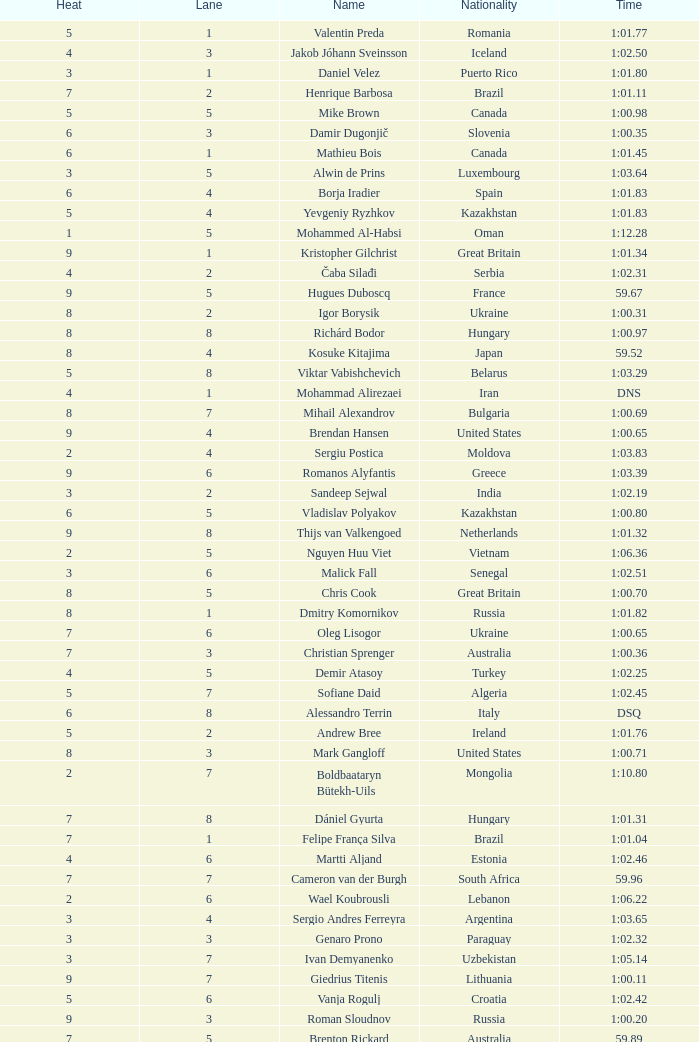What is the time in a heat smaller than 5, in Lane 5, for Vietnam? 1:06.36. 